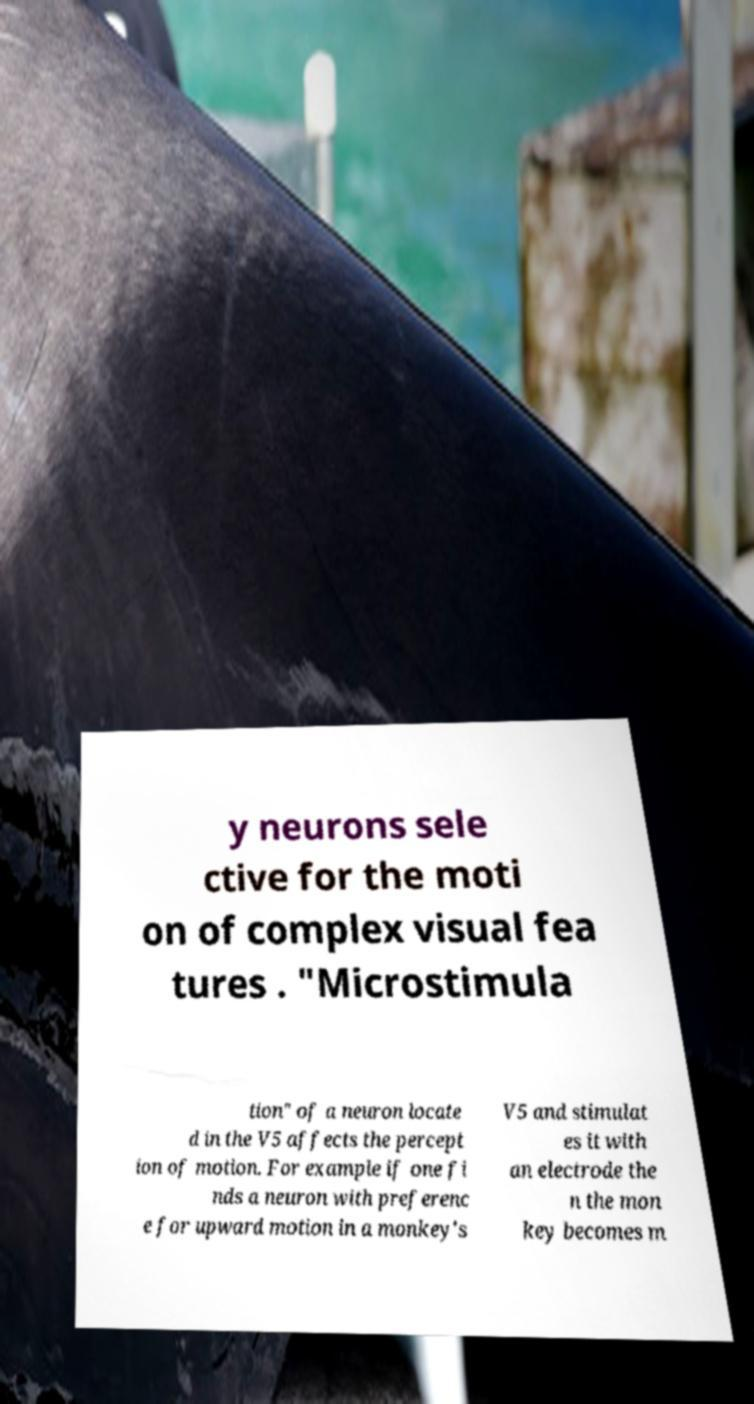Can you accurately transcribe the text from the provided image for me? y neurons sele ctive for the moti on of complex visual fea tures . "Microstimula tion" of a neuron locate d in the V5 affects the percept ion of motion. For example if one fi nds a neuron with preferenc e for upward motion in a monkey's V5 and stimulat es it with an electrode the n the mon key becomes m 